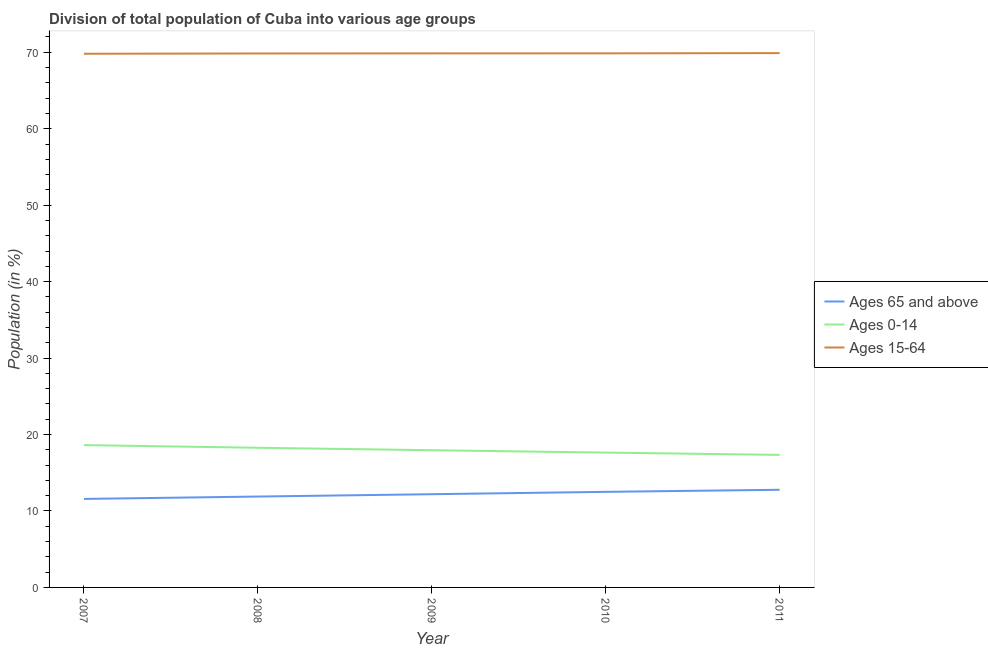How many different coloured lines are there?
Ensure brevity in your answer.  3. What is the percentage of population within the age-group 0-14 in 2007?
Offer a very short reply. 18.61. Across all years, what is the maximum percentage of population within the age-group of 65 and above?
Your answer should be compact. 12.77. Across all years, what is the minimum percentage of population within the age-group 0-14?
Provide a succinct answer. 17.34. In which year was the percentage of population within the age-group of 65 and above maximum?
Ensure brevity in your answer.  2011. What is the total percentage of population within the age-group 0-14 in the graph?
Make the answer very short. 89.81. What is the difference between the percentage of population within the age-group 15-64 in 2008 and that in 2009?
Give a very brief answer. -0.01. What is the difference between the percentage of population within the age-group 0-14 in 2007 and the percentage of population within the age-group 15-64 in 2011?
Offer a terse response. -51.28. What is the average percentage of population within the age-group of 65 and above per year?
Keep it short and to the point. 12.19. In the year 2008, what is the difference between the percentage of population within the age-group 0-14 and percentage of population within the age-group of 65 and above?
Your answer should be compact. 6.38. In how many years, is the percentage of population within the age-group of 65 and above greater than 40 %?
Offer a terse response. 0. What is the ratio of the percentage of population within the age-group 0-14 in 2010 to that in 2011?
Your answer should be very brief. 1.02. Is the percentage of population within the age-group 0-14 in 2007 less than that in 2010?
Ensure brevity in your answer.  No. What is the difference between the highest and the second highest percentage of population within the age-group 0-14?
Offer a very short reply. 0.35. What is the difference between the highest and the lowest percentage of population within the age-group 0-14?
Your response must be concise. 1.28. In how many years, is the percentage of population within the age-group of 65 and above greater than the average percentage of population within the age-group of 65 and above taken over all years?
Give a very brief answer. 3. Is the sum of the percentage of population within the age-group 15-64 in 2009 and 2011 greater than the maximum percentage of population within the age-group 0-14 across all years?
Make the answer very short. Yes. Is it the case that in every year, the sum of the percentage of population within the age-group of 65 and above and percentage of population within the age-group 0-14 is greater than the percentage of population within the age-group 15-64?
Make the answer very short. No. How many years are there in the graph?
Give a very brief answer. 5. What is the difference between two consecutive major ticks on the Y-axis?
Your answer should be very brief. 10. Does the graph contain grids?
Offer a very short reply. No. Where does the legend appear in the graph?
Your answer should be compact. Center right. What is the title of the graph?
Give a very brief answer. Division of total population of Cuba into various age groups
. Does "Domestic economy" appear as one of the legend labels in the graph?
Provide a short and direct response. No. What is the label or title of the X-axis?
Your answer should be very brief. Year. What is the Population (in %) of Ages 65 and above in 2007?
Provide a short and direct response. 11.58. What is the Population (in %) of Ages 0-14 in 2007?
Provide a succinct answer. 18.61. What is the Population (in %) in Ages 15-64 in 2007?
Keep it short and to the point. 69.81. What is the Population (in %) of Ages 65 and above in 2008?
Your answer should be very brief. 11.89. What is the Population (in %) of Ages 0-14 in 2008?
Keep it short and to the point. 18.27. What is the Population (in %) in Ages 15-64 in 2008?
Your response must be concise. 69.85. What is the Population (in %) in Ages 65 and above in 2009?
Keep it short and to the point. 12.19. What is the Population (in %) of Ages 0-14 in 2009?
Provide a succinct answer. 17.95. What is the Population (in %) of Ages 15-64 in 2009?
Offer a very short reply. 69.86. What is the Population (in %) of Ages 65 and above in 2010?
Give a very brief answer. 12.5. What is the Population (in %) in Ages 0-14 in 2010?
Keep it short and to the point. 17.64. What is the Population (in %) of Ages 15-64 in 2010?
Your answer should be compact. 69.86. What is the Population (in %) of Ages 65 and above in 2011?
Keep it short and to the point. 12.77. What is the Population (in %) in Ages 0-14 in 2011?
Provide a short and direct response. 17.34. What is the Population (in %) of Ages 15-64 in 2011?
Your answer should be very brief. 69.89. Across all years, what is the maximum Population (in %) of Ages 65 and above?
Your response must be concise. 12.77. Across all years, what is the maximum Population (in %) of Ages 0-14?
Give a very brief answer. 18.61. Across all years, what is the maximum Population (in %) in Ages 15-64?
Make the answer very short. 69.89. Across all years, what is the minimum Population (in %) of Ages 65 and above?
Provide a short and direct response. 11.58. Across all years, what is the minimum Population (in %) of Ages 0-14?
Your answer should be very brief. 17.34. Across all years, what is the minimum Population (in %) of Ages 15-64?
Give a very brief answer. 69.81. What is the total Population (in %) of Ages 65 and above in the graph?
Provide a succinct answer. 60.93. What is the total Population (in %) of Ages 0-14 in the graph?
Keep it short and to the point. 89.81. What is the total Population (in %) of Ages 15-64 in the graph?
Keep it short and to the point. 349.26. What is the difference between the Population (in %) in Ages 65 and above in 2007 and that in 2008?
Keep it short and to the point. -0.31. What is the difference between the Population (in %) in Ages 0-14 in 2007 and that in 2008?
Your answer should be compact. 0.35. What is the difference between the Population (in %) in Ages 15-64 in 2007 and that in 2008?
Make the answer very short. -0.04. What is the difference between the Population (in %) in Ages 65 and above in 2007 and that in 2009?
Keep it short and to the point. -0.62. What is the difference between the Population (in %) of Ages 0-14 in 2007 and that in 2009?
Make the answer very short. 0.67. What is the difference between the Population (in %) of Ages 15-64 in 2007 and that in 2009?
Keep it short and to the point. -0.05. What is the difference between the Population (in %) of Ages 65 and above in 2007 and that in 2010?
Ensure brevity in your answer.  -0.92. What is the difference between the Population (in %) of Ages 0-14 in 2007 and that in 2010?
Provide a succinct answer. 0.98. What is the difference between the Population (in %) in Ages 15-64 in 2007 and that in 2010?
Ensure brevity in your answer.  -0.05. What is the difference between the Population (in %) in Ages 65 and above in 2007 and that in 2011?
Ensure brevity in your answer.  -1.2. What is the difference between the Population (in %) in Ages 0-14 in 2007 and that in 2011?
Offer a very short reply. 1.28. What is the difference between the Population (in %) in Ages 15-64 in 2007 and that in 2011?
Keep it short and to the point. -0.08. What is the difference between the Population (in %) of Ages 65 and above in 2008 and that in 2009?
Provide a succinct answer. -0.31. What is the difference between the Population (in %) of Ages 0-14 in 2008 and that in 2009?
Your answer should be very brief. 0.32. What is the difference between the Population (in %) of Ages 15-64 in 2008 and that in 2009?
Give a very brief answer. -0.01. What is the difference between the Population (in %) in Ages 65 and above in 2008 and that in 2010?
Give a very brief answer. -0.62. What is the difference between the Population (in %) of Ages 0-14 in 2008 and that in 2010?
Offer a terse response. 0.63. What is the difference between the Population (in %) of Ages 15-64 in 2008 and that in 2010?
Ensure brevity in your answer.  -0.01. What is the difference between the Population (in %) of Ages 65 and above in 2008 and that in 2011?
Provide a succinct answer. -0.89. What is the difference between the Population (in %) in Ages 0-14 in 2008 and that in 2011?
Ensure brevity in your answer.  0.93. What is the difference between the Population (in %) in Ages 15-64 in 2008 and that in 2011?
Give a very brief answer. -0.05. What is the difference between the Population (in %) in Ages 65 and above in 2009 and that in 2010?
Give a very brief answer. -0.31. What is the difference between the Population (in %) of Ages 0-14 in 2009 and that in 2010?
Offer a terse response. 0.31. What is the difference between the Population (in %) of Ages 15-64 in 2009 and that in 2010?
Offer a terse response. -0. What is the difference between the Population (in %) in Ages 65 and above in 2009 and that in 2011?
Offer a terse response. -0.58. What is the difference between the Population (in %) in Ages 0-14 in 2009 and that in 2011?
Offer a very short reply. 0.61. What is the difference between the Population (in %) of Ages 15-64 in 2009 and that in 2011?
Make the answer very short. -0.03. What is the difference between the Population (in %) of Ages 65 and above in 2010 and that in 2011?
Offer a very short reply. -0.27. What is the difference between the Population (in %) of Ages 0-14 in 2010 and that in 2011?
Provide a succinct answer. 0.3. What is the difference between the Population (in %) in Ages 15-64 in 2010 and that in 2011?
Your response must be concise. -0.03. What is the difference between the Population (in %) of Ages 65 and above in 2007 and the Population (in %) of Ages 0-14 in 2008?
Give a very brief answer. -6.69. What is the difference between the Population (in %) in Ages 65 and above in 2007 and the Population (in %) in Ages 15-64 in 2008?
Offer a very short reply. -58.27. What is the difference between the Population (in %) in Ages 0-14 in 2007 and the Population (in %) in Ages 15-64 in 2008?
Provide a short and direct response. -51.23. What is the difference between the Population (in %) of Ages 65 and above in 2007 and the Population (in %) of Ages 0-14 in 2009?
Your response must be concise. -6.37. What is the difference between the Population (in %) of Ages 65 and above in 2007 and the Population (in %) of Ages 15-64 in 2009?
Your answer should be very brief. -58.28. What is the difference between the Population (in %) of Ages 0-14 in 2007 and the Population (in %) of Ages 15-64 in 2009?
Offer a terse response. -51.24. What is the difference between the Population (in %) in Ages 65 and above in 2007 and the Population (in %) in Ages 0-14 in 2010?
Keep it short and to the point. -6.06. What is the difference between the Population (in %) of Ages 65 and above in 2007 and the Population (in %) of Ages 15-64 in 2010?
Provide a short and direct response. -58.28. What is the difference between the Population (in %) of Ages 0-14 in 2007 and the Population (in %) of Ages 15-64 in 2010?
Offer a terse response. -51.25. What is the difference between the Population (in %) in Ages 65 and above in 2007 and the Population (in %) in Ages 0-14 in 2011?
Keep it short and to the point. -5.76. What is the difference between the Population (in %) of Ages 65 and above in 2007 and the Population (in %) of Ages 15-64 in 2011?
Provide a succinct answer. -58.31. What is the difference between the Population (in %) in Ages 0-14 in 2007 and the Population (in %) in Ages 15-64 in 2011?
Offer a very short reply. -51.28. What is the difference between the Population (in %) in Ages 65 and above in 2008 and the Population (in %) in Ages 0-14 in 2009?
Your answer should be very brief. -6.06. What is the difference between the Population (in %) in Ages 65 and above in 2008 and the Population (in %) in Ages 15-64 in 2009?
Ensure brevity in your answer.  -57.97. What is the difference between the Population (in %) in Ages 0-14 in 2008 and the Population (in %) in Ages 15-64 in 2009?
Give a very brief answer. -51.59. What is the difference between the Population (in %) in Ages 65 and above in 2008 and the Population (in %) in Ages 0-14 in 2010?
Make the answer very short. -5.75. What is the difference between the Population (in %) of Ages 65 and above in 2008 and the Population (in %) of Ages 15-64 in 2010?
Keep it short and to the point. -57.97. What is the difference between the Population (in %) in Ages 0-14 in 2008 and the Population (in %) in Ages 15-64 in 2010?
Provide a succinct answer. -51.59. What is the difference between the Population (in %) of Ages 65 and above in 2008 and the Population (in %) of Ages 0-14 in 2011?
Give a very brief answer. -5.45. What is the difference between the Population (in %) of Ages 65 and above in 2008 and the Population (in %) of Ages 15-64 in 2011?
Provide a short and direct response. -58. What is the difference between the Population (in %) of Ages 0-14 in 2008 and the Population (in %) of Ages 15-64 in 2011?
Keep it short and to the point. -51.62. What is the difference between the Population (in %) in Ages 65 and above in 2009 and the Population (in %) in Ages 0-14 in 2010?
Offer a terse response. -5.44. What is the difference between the Population (in %) of Ages 65 and above in 2009 and the Population (in %) of Ages 15-64 in 2010?
Your answer should be very brief. -57.67. What is the difference between the Population (in %) of Ages 0-14 in 2009 and the Population (in %) of Ages 15-64 in 2010?
Make the answer very short. -51.91. What is the difference between the Population (in %) of Ages 65 and above in 2009 and the Population (in %) of Ages 0-14 in 2011?
Ensure brevity in your answer.  -5.14. What is the difference between the Population (in %) of Ages 65 and above in 2009 and the Population (in %) of Ages 15-64 in 2011?
Give a very brief answer. -57.7. What is the difference between the Population (in %) of Ages 0-14 in 2009 and the Population (in %) of Ages 15-64 in 2011?
Make the answer very short. -51.94. What is the difference between the Population (in %) of Ages 65 and above in 2010 and the Population (in %) of Ages 0-14 in 2011?
Ensure brevity in your answer.  -4.83. What is the difference between the Population (in %) in Ages 65 and above in 2010 and the Population (in %) in Ages 15-64 in 2011?
Ensure brevity in your answer.  -57.39. What is the difference between the Population (in %) of Ages 0-14 in 2010 and the Population (in %) of Ages 15-64 in 2011?
Provide a succinct answer. -52.25. What is the average Population (in %) of Ages 65 and above per year?
Your answer should be very brief. 12.19. What is the average Population (in %) of Ages 0-14 per year?
Give a very brief answer. 17.96. What is the average Population (in %) of Ages 15-64 per year?
Your answer should be compact. 69.85. In the year 2007, what is the difference between the Population (in %) in Ages 65 and above and Population (in %) in Ages 0-14?
Your answer should be very brief. -7.04. In the year 2007, what is the difference between the Population (in %) in Ages 65 and above and Population (in %) in Ages 15-64?
Your response must be concise. -58.23. In the year 2007, what is the difference between the Population (in %) of Ages 0-14 and Population (in %) of Ages 15-64?
Your response must be concise. -51.19. In the year 2008, what is the difference between the Population (in %) of Ages 65 and above and Population (in %) of Ages 0-14?
Offer a terse response. -6.38. In the year 2008, what is the difference between the Population (in %) in Ages 65 and above and Population (in %) in Ages 15-64?
Your answer should be compact. -57.96. In the year 2008, what is the difference between the Population (in %) in Ages 0-14 and Population (in %) in Ages 15-64?
Offer a very short reply. -51.58. In the year 2009, what is the difference between the Population (in %) of Ages 65 and above and Population (in %) of Ages 0-14?
Your answer should be very brief. -5.75. In the year 2009, what is the difference between the Population (in %) in Ages 65 and above and Population (in %) in Ages 15-64?
Ensure brevity in your answer.  -57.66. In the year 2009, what is the difference between the Population (in %) in Ages 0-14 and Population (in %) in Ages 15-64?
Keep it short and to the point. -51.91. In the year 2010, what is the difference between the Population (in %) in Ages 65 and above and Population (in %) in Ages 0-14?
Provide a short and direct response. -5.14. In the year 2010, what is the difference between the Population (in %) of Ages 65 and above and Population (in %) of Ages 15-64?
Offer a very short reply. -57.36. In the year 2010, what is the difference between the Population (in %) of Ages 0-14 and Population (in %) of Ages 15-64?
Give a very brief answer. -52.22. In the year 2011, what is the difference between the Population (in %) of Ages 65 and above and Population (in %) of Ages 0-14?
Ensure brevity in your answer.  -4.56. In the year 2011, what is the difference between the Population (in %) of Ages 65 and above and Population (in %) of Ages 15-64?
Give a very brief answer. -57.12. In the year 2011, what is the difference between the Population (in %) of Ages 0-14 and Population (in %) of Ages 15-64?
Offer a terse response. -52.55. What is the ratio of the Population (in %) of Ages 0-14 in 2007 to that in 2008?
Your response must be concise. 1.02. What is the ratio of the Population (in %) of Ages 65 and above in 2007 to that in 2009?
Your answer should be very brief. 0.95. What is the ratio of the Population (in %) in Ages 0-14 in 2007 to that in 2009?
Ensure brevity in your answer.  1.04. What is the ratio of the Population (in %) in Ages 65 and above in 2007 to that in 2010?
Provide a short and direct response. 0.93. What is the ratio of the Population (in %) in Ages 0-14 in 2007 to that in 2010?
Your answer should be very brief. 1.06. What is the ratio of the Population (in %) of Ages 65 and above in 2007 to that in 2011?
Make the answer very short. 0.91. What is the ratio of the Population (in %) in Ages 0-14 in 2007 to that in 2011?
Provide a short and direct response. 1.07. What is the ratio of the Population (in %) of Ages 65 and above in 2008 to that in 2009?
Your answer should be compact. 0.97. What is the ratio of the Population (in %) of Ages 0-14 in 2008 to that in 2009?
Your answer should be very brief. 1.02. What is the ratio of the Population (in %) of Ages 15-64 in 2008 to that in 2009?
Offer a very short reply. 1. What is the ratio of the Population (in %) in Ages 65 and above in 2008 to that in 2010?
Your answer should be very brief. 0.95. What is the ratio of the Population (in %) in Ages 0-14 in 2008 to that in 2010?
Ensure brevity in your answer.  1.04. What is the ratio of the Population (in %) in Ages 65 and above in 2008 to that in 2011?
Provide a short and direct response. 0.93. What is the ratio of the Population (in %) in Ages 0-14 in 2008 to that in 2011?
Provide a succinct answer. 1.05. What is the ratio of the Population (in %) in Ages 15-64 in 2008 to that in 2011?
Provide a short and direct response. 1. What is the ratio of the Population (in %) in Ages 65 and above in 2009 to that in 2010?
Your response must be concise. 0.98. What is the ratio of the Population (in %) in Ages 0-14 in 2009 to that in 2010?
Offer a terse response. 1.02. What is the ratio of the Population (in %) of Ages 15-64 in 2009 to that in 2010?
Your answer should be very brief. 1. What is the ratio of the Population (in %) in Ages 65 and above in 2009 to that in 2011?
Your answer should be very brief. 0.95. What is the ratio of the Population (in %) of Ages 0-14 in 2009 to that in 2011?
Provide a succinct answer. 1.04. What is the ratio of the Population (in %) of Ages 65 and above in 2010 to that in 2011?
Provide a succinct answer. 0.98. What is the ratio of the Population (in %) in Ages 0-14 in 2010 to that in 2011?
Give a very brief answer. 1.02. What is the difference between the highest and the second highest Population (in %) of Ages 65 and above?
Offer a terse response. 0.27. What is the difference between the highest and the second highest Population (in %) in Ages 0-14?
Offer a very short reply. 0.35. What is the difference between the highest and the second highest Population (in %) of Ages 15-64?
Make the answer very short. 0.03. What is the difference between the highest and the lowest Population (in %) in Ages 65 and above?
Provide a short and direct response. 1.2. What is the difference between the highest and the lowest Population (in %) of Ages 0-14?
Provide a short and direct response. 1.28. What is the difference between the highest and the lowest Population (in %) of Ages 15-64?
Your answer should be compact. 0.08. 